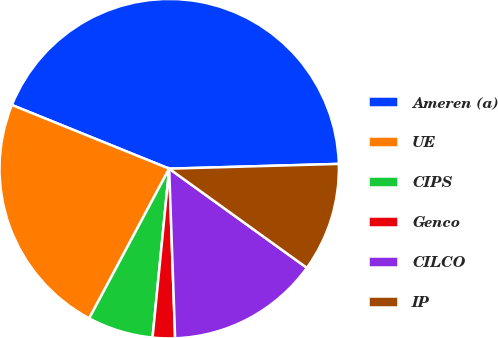Convert chart to OTSL. <chart><loc_0><loc_0><loc_500><loc_500><pie_chart><fcel>Ameren (a)<fcel>UE<fcel>CIPS<fcel>Genco<fcel>CILCO<fcel>IP<nl><fcel>43.43%<fcel>23.31%<fcel>6.25%<fcel>2.12%<fcel>14.51%<fcel>10.38%<nl></chart> 